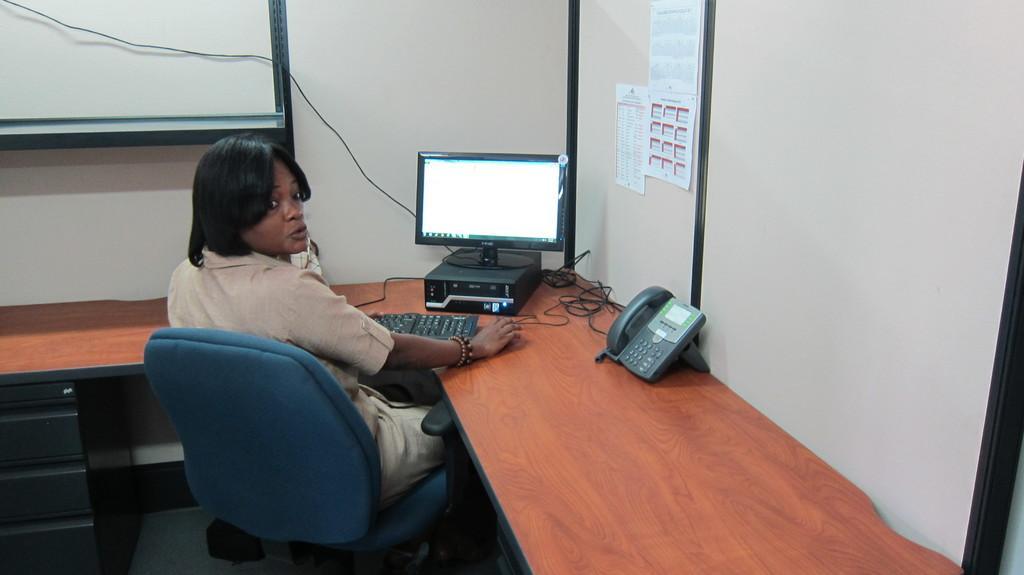How would you summarize this image in a sentence or two? In this picture we can see a woman is sitting on a chair, and in front here is the table and keyboard and system and telephone on it. and at back here is the wall and papers on it. 